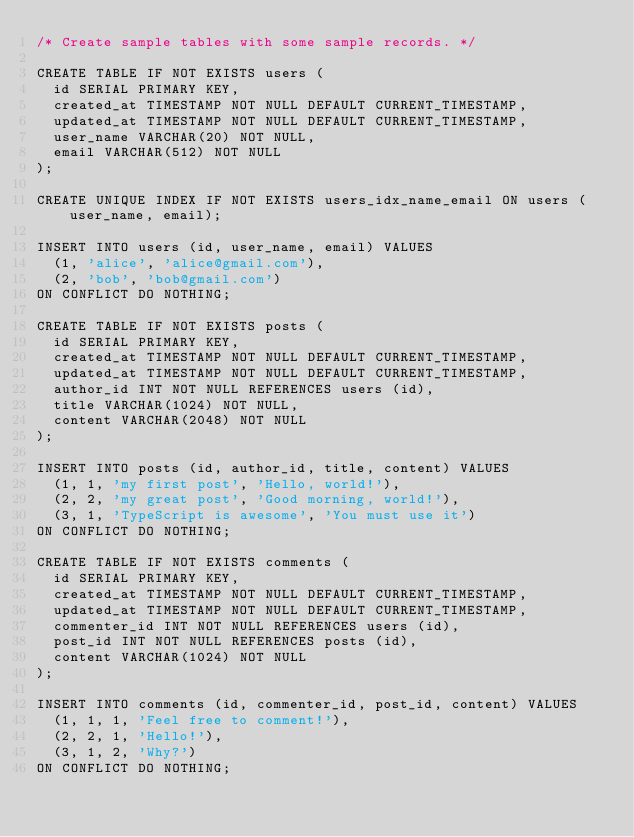<code> <loc_0><loc_0><loc_500><loc_500><_SQL_>/* Create sample tables with some sample records. */

CREATE TABLE IF NOT EXISTS users (
  id SERIAL PRIMARY KEY,
  created_at TIMESTAMP NOT NULL DEFAULT CURRENT_TIMESTAMP,
  updated_at TIMESTAMP NOT NULL DEFAULT CURRENT_TIMESTAMP,
  user_name VARCHAR(20) NOT NULL,
  email VARCHAR(512) NOT NULL
);

CREATE UNIQUE INDEX IF NOT EXISTS users_idx_name_email ON users (user_name, email);

INSERT INTO users (id, user_name, email) VALUES
  (1, 'alice', 'alice@gmail.com'),
  (2, 'bob', 'bob@gmail.com')
ON CONFLICT DO NOTHING;

CREATE TABLE IF NOT EXISTS posts (
  id SERIAL PRIMARY KEY,
  created_at TIMESTAMP NOT NULL DEFAULT CURRENT_TIMESTAMP,
  updated_at TIMESTAMP NOT NULL DEFAULT CURRENT_TIMESTAMP,
  author_id INT NOT NULL REFERENCES users (id),
  title VARCHAR(1024) NOT NULL,
  content VARCHAR(2048) NOT NULL
);

INSERT INTO posts (id, author_id, title, content) VALUES
  (1, 1, 'my first post', 'Hello, world!'),
  (2, 2, 'my great post', 'Good morning, world!'),
  (3, 1, 'TypeScript is awesome', 'You must use it')
ON CONFLICT DO NOTHING;

CREATE TABLE IF NOT EXISTS comments (
  id SERIAL PRIMARY KEY,
  created_at TIMESTAMP NOT NULL DEFAULT CURRENT_TIMESTAMP,
  updated_at TIMESTAMP NOT NULL DEFAULT CURRENT_TIMESTAMP,
  commenter_id INT NOT NULL REFERENCES users (id),
  post_id INT NOT NULL REFERENCES posts (id),
  content VARCHAR(1024) NOT NULL
);

INSERT INTO comments (id, commenter_id, post_id, content) VALUES
  (1, 1, 1, 'Feel free to comment!'),
  (2, 2, 1, 'Hello!'),
  (3, 1, 2, 'Why?')
ON CONFLICT DO NOTHING;
</code> 